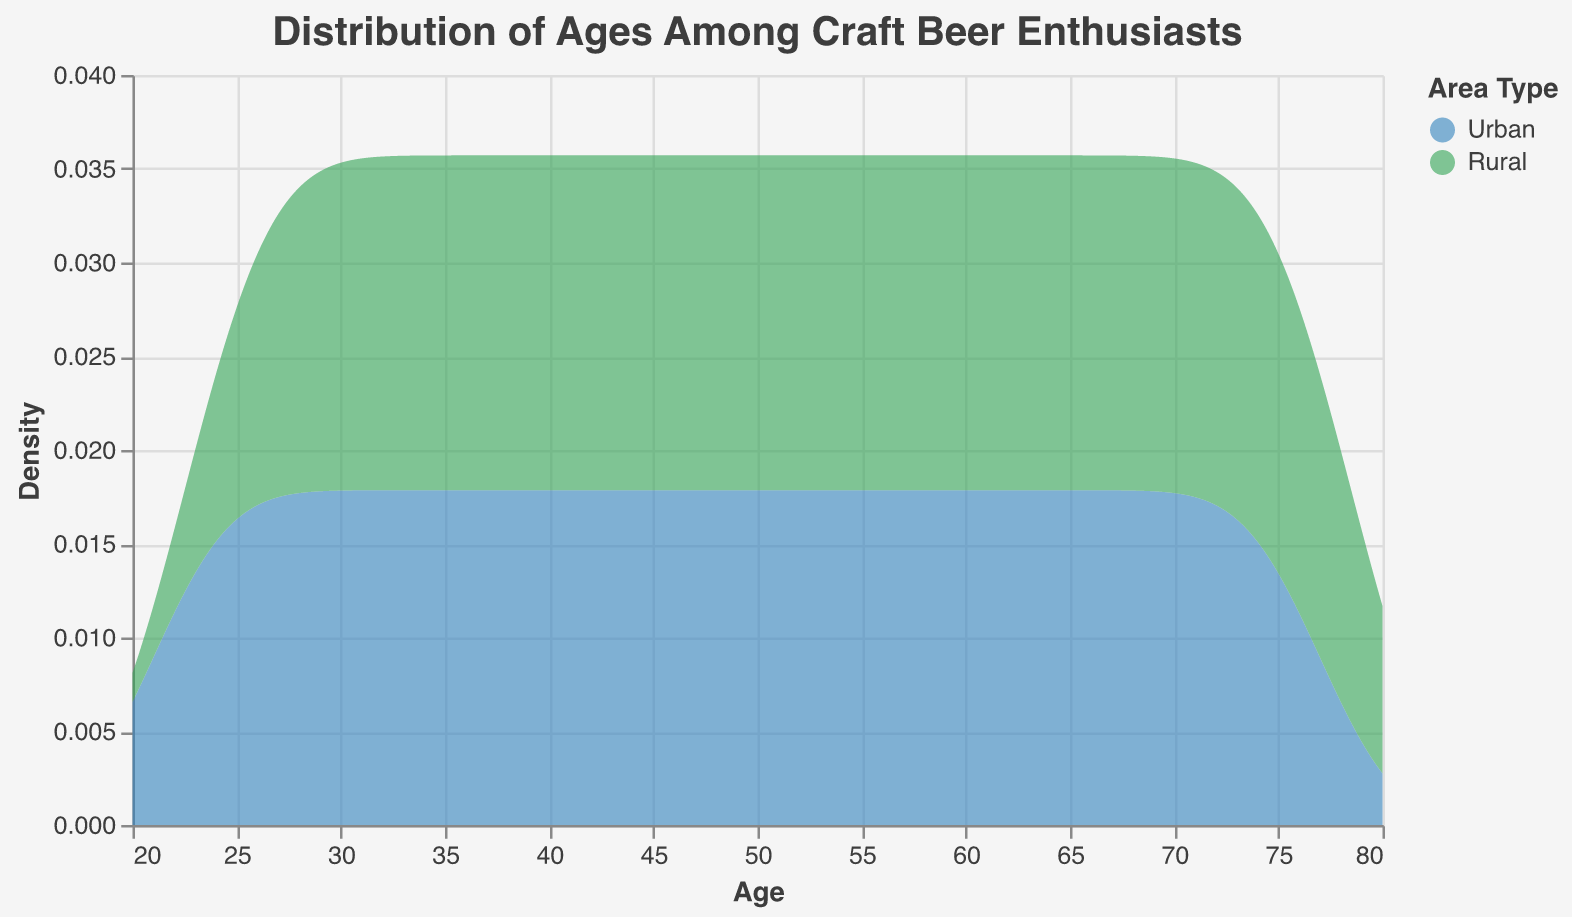What is the title of the figure? The title of the figure is displayed prominently at the top and can be read directly from the provided information.
Answer: Distribution of Ages Among Craft Beer Enthusiasts What does the x-axis represent? The labeling on the x-axis indicates that it shows the variable being measured on this axis.
Answer: Age What does the y-axis represent? The labeling on the y-axis indicates that it shows how the data is distributed.
Answer: Density What colors represent Urban and Rural areas, respectively? The color legend indicates that Urban areas are represented by blue and Rural areas by green.
Answer: Blue, Green In which age range do Urban craft beer enthusiasts have the highest density? The density plot for Urban areas shows the peak where the density is highest.
Answer: 36-40 Which group has a broader age range among craft beer enthusiasts? By comparing the spread of the density plots, it can be seen which group has data points over a wider age span.
Answer: Rural At what age does the density for Rural craft beer enthusiasts start to increase? The density plot for Rural areas indicates the age at which the density curve begins to rise from zero.
Answer: 25 How do the age distributions compare between Urban and Rural areas? The density plots for Urban and Rural areas show where the ages are concentrated, and if one group's ages are more spread out.
Answer: Rural area enthusiasts have a slightly broader age range and a peak at older ages compared to Urban enthusiasts At around what age do the densities of Urban and Rural areas intersect? Identify the point where the blue and green areas overlap, indicating an equal density.
Answer: Approximately 35-40 